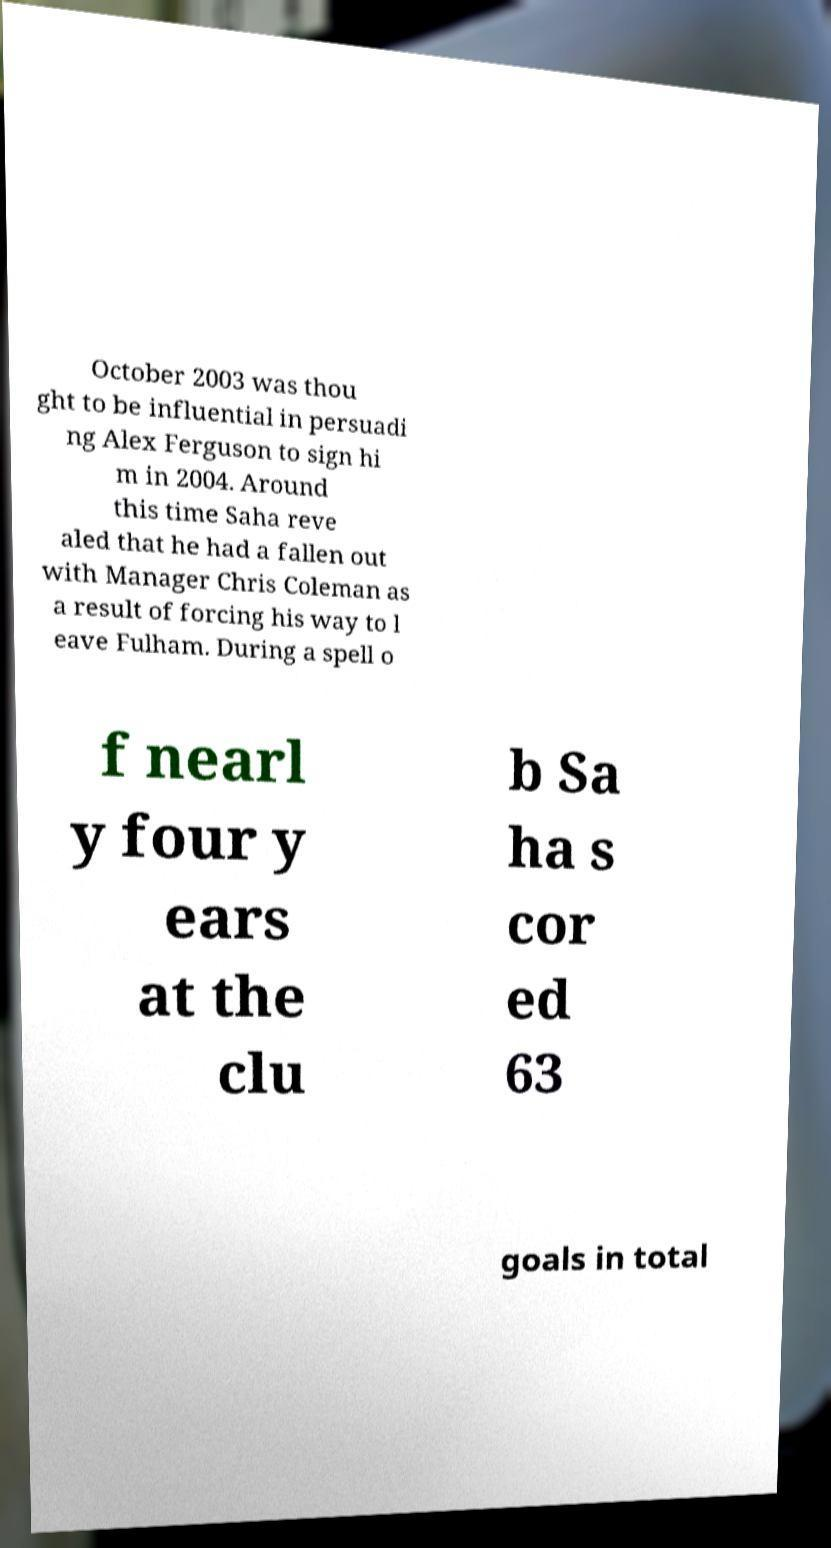Can you accurately transcribe the text from the provided image for me? October 2003 was thou ght to be influential in persuadi ng Alex Ferguson to sign hi m in 2004. Around this time Saha reve aled that he had a fallen out with Manager Chris Coleman as a result of forcing his way to l eave Fulham. During a spell o f nearl y four y ears at the clu b Sa ha s cor ed 63 goals in total 